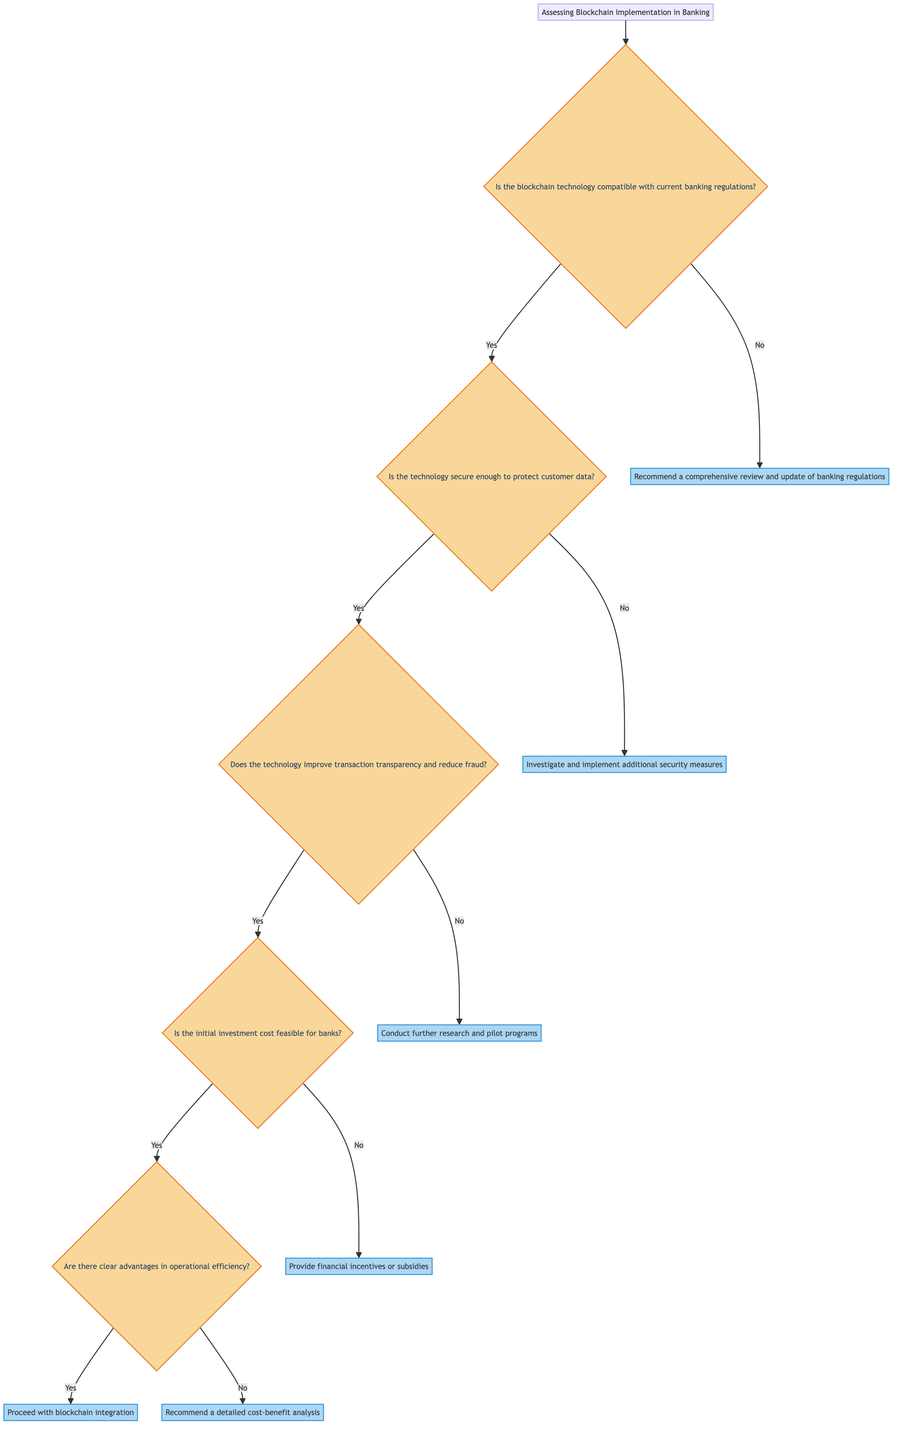What is the starting node in the decision tree? The starting node is labeled as "Assessing Blockchain Implementation in Banking," which is the first point in the diagram from which all other nodes branch out.
Answer: Assessing Blockchain Implementation in Banking How many total nodes are in the diagram? There are 12 nodes in total: one start node and eleven additional nodes representing questions and actions throughout the decision tree.
Answer: 12 Which node leads to recommending a comprehensive review of banking regulations? The action to recommend a comprehensive review occurs when the answer to the question regarding compatibility with banking regulations is "No," which is found at node 3 in the diagram.
Answer: Recommend a comprehensive review and update of banking regulations If the technology is secure but does not improve transaction transparency, what action is recommended? Following the path from the "Is the technology secure enough?" question, if the answer is "No" to the transparency question, the action taken is to conduct further research and pilot programs. This is indicated at node 7.
Answer: Conduct further research and pilot programs What happens if the initial investment cost for blockchain implementation is not feasible for banks? If the initial investment cost is deemed unfeasible (answer "No" at node 6), the next action is to provide financial incentives or subsidies to support blockchain adoption in the banking sector, which is found at node 9.
Answer: Provide financial incentives or subsidies What do you need to determine after confirming that the technology improves transaction transparency and reduces fraud? After confirming the improvement in transaction transparency and fraud reduction (a "Yes" answer at node 4), the next step is to determine if the initial investment cost is feasible for banks, which leads to node 6.
Answer: Is the initial investment cost for blockchain implementation feasible for banks? What is the final outcome if there are clear advantages in operational efficiency and cost reduction? If it is concluded that there are clear advantages in operational efficiency and cost reduction (a "Yes" answer at node 10), the final action is to proceed with blockchain integration and begin formulating regulatory guidelines, indicated at node 10.
Answer: Proceed with blockchain integration and start formulating regulatory guidelines What action does the diagram suggest if security measures are found to be insufficient? If the technology is not secure enough to protect customer data (a "No" answer at node 2), the recommendation is to investigate and implement additional security measures or alternative technologies, represented at node 5.
Answer: Investigate and implement additional security measures or alternative technologies 